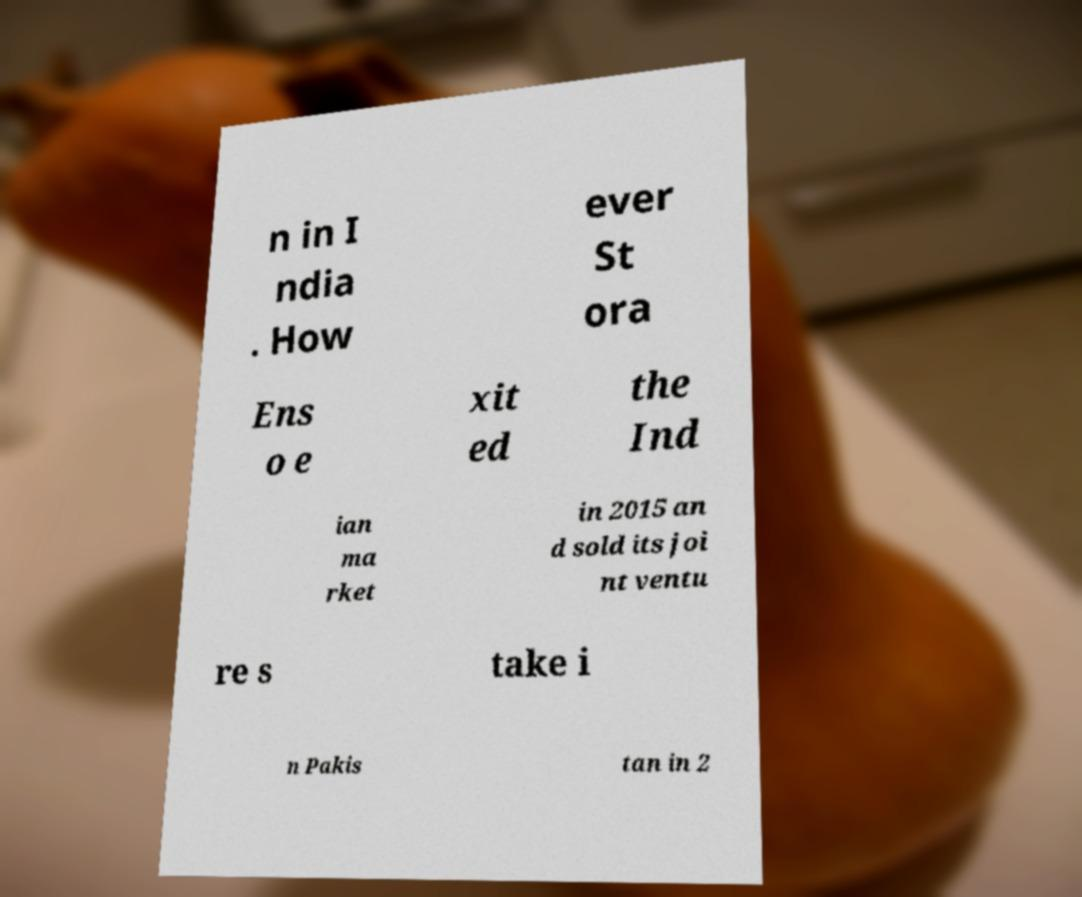What messages or text are displayed in this image? I need them in a readable, typed format. n in I ndia . How ever St ora Ens o e xit ed the Ind ian ma rket in 2015 an d sold its joi nt ventu re s take i n Pakis tan in 2 